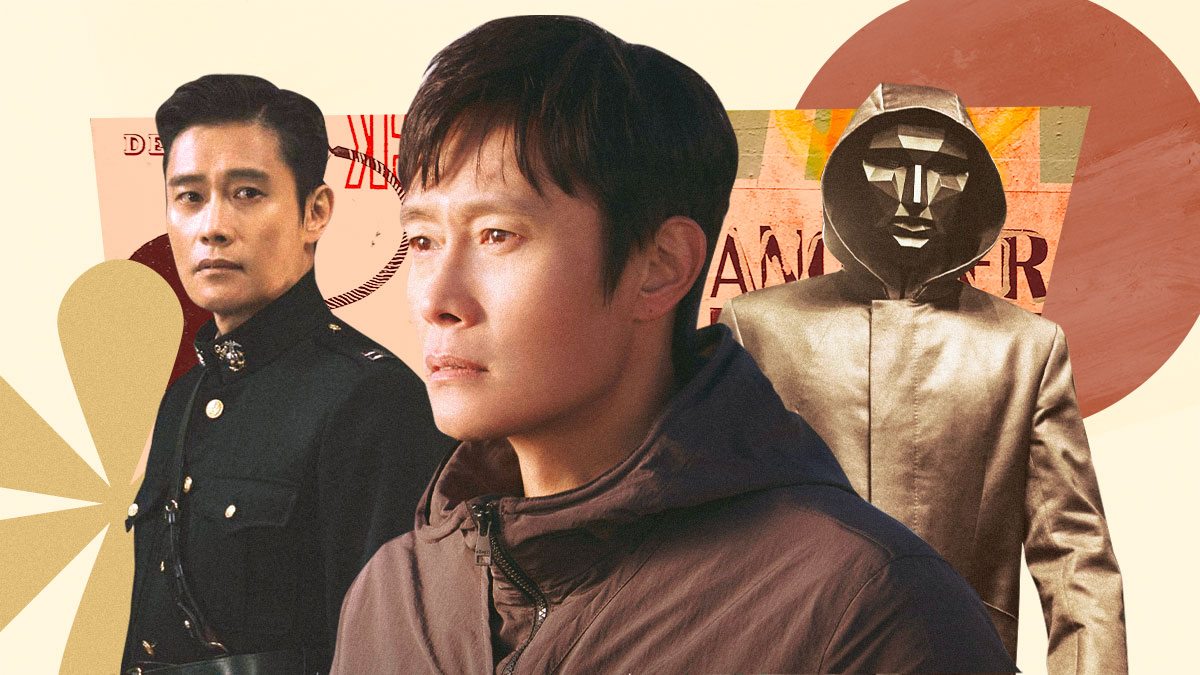What do you see happening in this image? This image captures the versatile South Korean actor Lee Byung-hun in three distinct roles. On the left, Lee Byung-hun stands tall in a black military uniform adorned with gold epaulettes and a striking red collar, exuding an air of authority. In the center, he is seen in a more casual light, donning a brown jacket and gazing off to the side with a serious expression, perhaps deep in thought. To the right, he takes on a more mysterious persona, his face hidden behind a mask while wearing a gold hooded jacket. The background is an abstract blend of warm hues - orange, yellow, and red - against a pale peach canvas, subtly highlighting the actor's transformative range. 